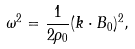<formula> <loc_0><loc_0><loc_500><loc_500>\omega ^ { 2 } = \frac { 1 } { 2 \rho _ { 0 } } ( { k \cdot B _ { 0 } } ) ^ { 2 } ,</formula> 